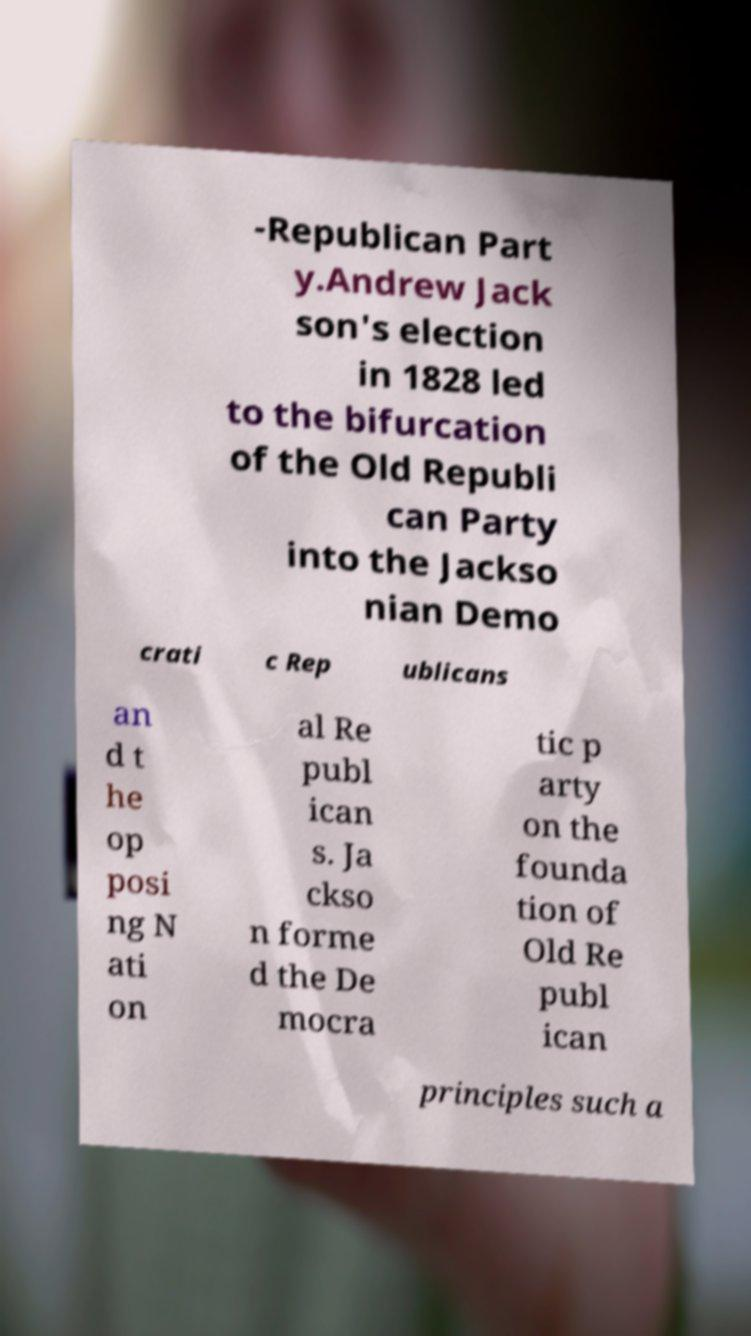Can you read and provide the text displayed in the image?This photo seems to have some interesting text. Can you extract and type it out for me? -Republican Part y.Andrew Jack son's election in 1828 led to the bifurcation of the Old Republi can Party into the Jackso nian Demo crati c Rep ublicans an d t he op posi ng N ati on al Re publ ican s. Ja ckso n forme d the De mocra tic p arty on the founda tion of Old Re publ ican principles such a 